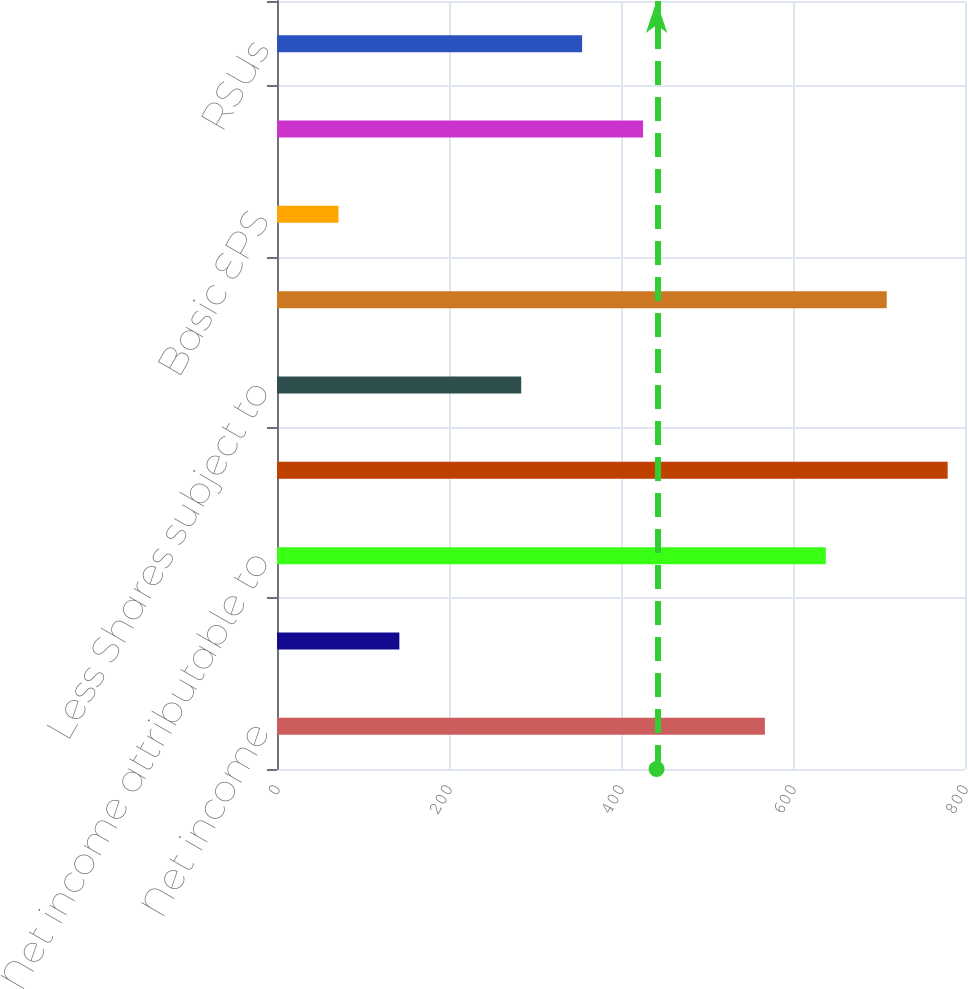<chart> <loc_0><loc_0><loc_500><loc_500><bar_chart><fcel>Net income<fcel>Less Net income attributable<fcel>Net income attributable to<fcel>Weighted average shares<fcel>Less Shares subject to<fcel>Number of shares used for<fcel>Basic EPS<fcel>Employee stock options<fcel>RSUs<nl><fcel>567.32<fcel>142.28<fcel>638.16<fcel>779.84<fcel>283.96<fcel>709<fcel>71.44<fcel>425.64<fcel>354.8<nl></chart> 